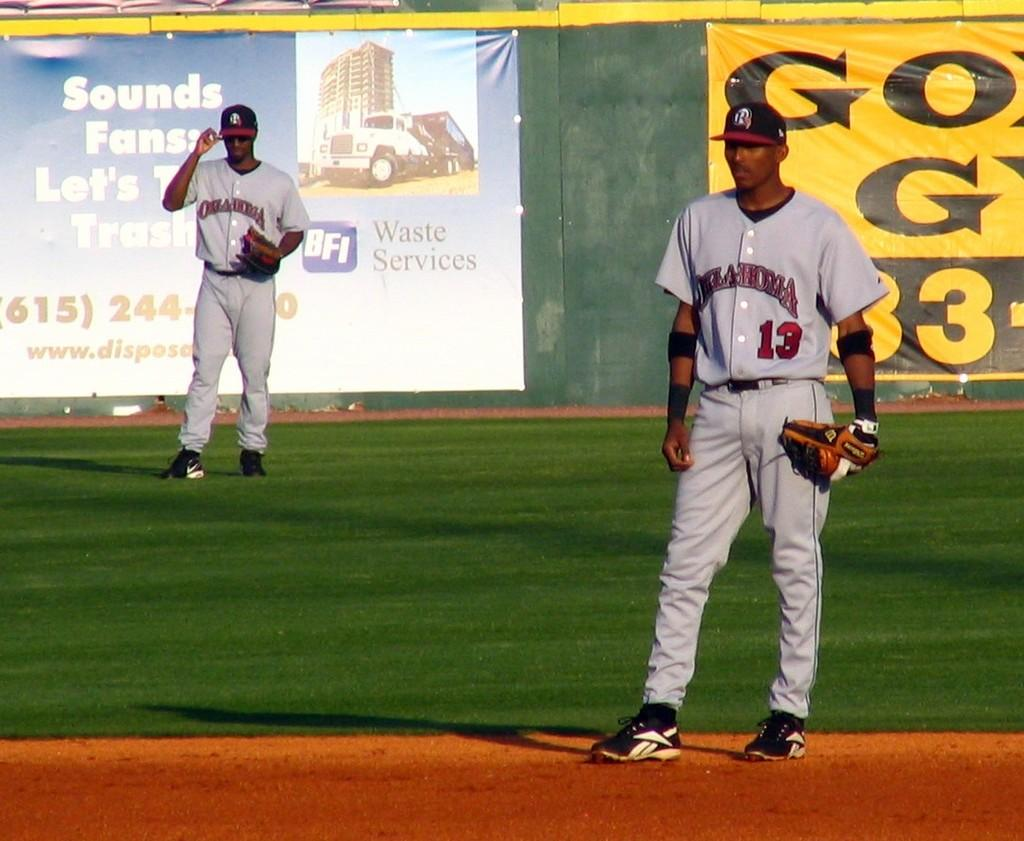<image>
Provide a brief description of the given image. An Oklahoma baseball pitcher is standing on the mound. 